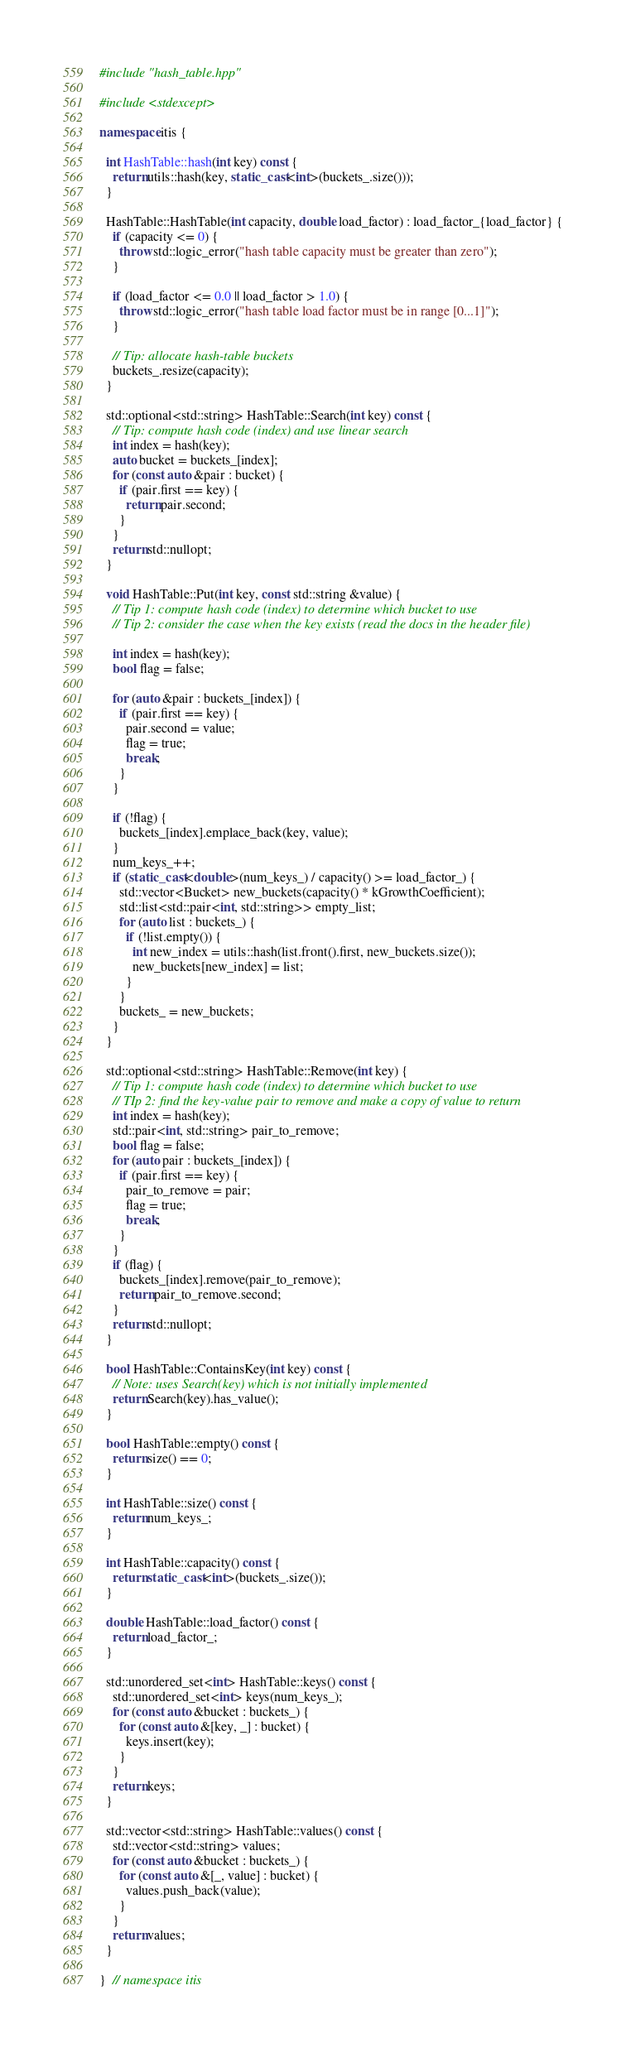Convert code to text. <code><loc_0><loc_0><loc_500><loc_500><_C++_>#include "hash_table.hpp"

#include <stdexcept>

namespace itis {

  int HashTable::hash(int key) const {
    return utils::hash(key, static_cast<int>(buckets_.size()));
  }

  HashTable::HashTable(int capacity, double load_factor) : load_factor_{load_factor} {
    if (capacity <= 0) {
      throw std::logic_error("hash table capacity must be greater than zero");
    }

    if (load_factor <= 0.0 || load_factor > 1.0) {
      throw std::logic_error("hash table load factor must be in range [0...1]");
    }

    // Tip: allocate hash-table buckets
    buckets_.resize(capacity);
  }

  std::optional<std::string> HashTable::Search(int key) const {
    // Tip: compute hash code (index) and use linear search
    int index = hash(key);
    auto bucket = buckets_[index];
    for (const auto &pair : bucket) {
      if (pair.first == key) {
        return pair.second;
      }
    }
    return std::nullopt;
  }

  void HashTable::Put(int key, const std::string &value) {
    // Tip 1: compute hash code (index) to determine which bucket to use
    // Tip 2: consider the case when the key exists (read the docs in the header file)

    int index = hash(key);
    bool flag = false;

    for (auto &pair : buckets_[index]) {
      if (pair.first == key) {
        pair.second = value;
        flag = true;
        break;
      }
    }

    if (!flag) {
      buckets_[index].emplace_back(key, value);
    }
    num_keys_++;
    if (static_cast<double>(num_keys_) / capacity() >= load_factor_) {
      std::vector<Bucket> new_buckets(capacity() * kGrowthCoefficient);
      std::list<std::pair<int, std::string>> empty_list;
      for (auto list : buckets_) {
        if (!list.empty()) {
          int new_index = utils::hash(list.front().first, new_buckets.size());
          new_buckets[new_index] = list;
        }
      }
      buckets_ = new_buckets;
    }
  }

  std::optional<std::string> HashTable::Remove(int key) {
    // Tip 1: compute hash code (index) to determine which bucket to use
    // TIp 2: find the key-value pair to remove and make a copy of value to return
    int index = hash(key);
    std::pair<int, std::string> pair_to_remove;
    bool flag = false;
    for (auto pair : buckets_[index]) {
      if (pair.first == key) {
        pair_to_remove = pair;
        flag = true;
        break;
      }
    }
    if (flag) {
      buckets_[index].remove(pair_to_remove);
      return pair_to_remove.second;
    }
    return std::nullopt;
  }

  bool HashTable::ContainsKey(int key) const {
    // Note: uses Search(key) which is not initially implemented
    return Search(key).has_value();
  }

  bool HashTable::empty() const {
    return size() == 0;
  }

  int HashTable::size() const {
    return num_keys_;
  }

  int HashTable::capacity() const {
    return static_cast<int>(buckets_.size());
  }

  double HashTable::load_factor() const {
    return load_factor_;
  }

  std::unordered_set<int> HashTable::keys() const {
    std::unordered_set<int> keys(num_keys_);
    for (const auto &bucket : buckets_) {
      for (const auto &[key, _] : bucket) {
        keys.insert(key);
      }
    }
    return keys;
  }

  std::vector<std::string> HashTable::values() const {
    std::vector<std::string> values;
    for (const auto &bucket : buckets_) {
      for (const auto &[_, value] : bucket) {
        values.push_back(value);
      }
    }
    return values;
  }

}  // namespace itis</code> 